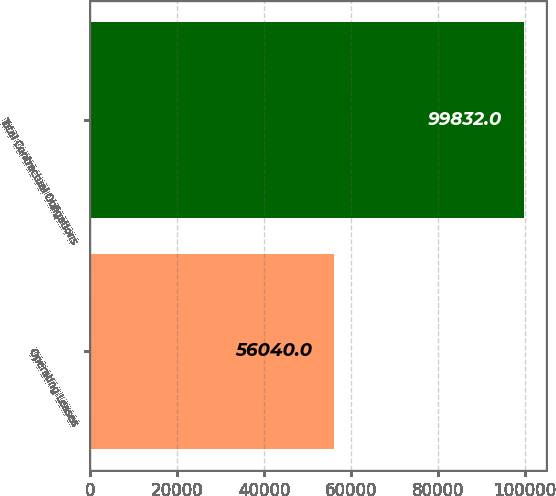Convert chart to OTSL. <chart><loc_0><loc_0><loc_500><loc_500><bar_chart><fcel>Operating Leases<fcel>Total Contractual Obligations<nl><fcel>56040<fcel>99832<nl></chart> 